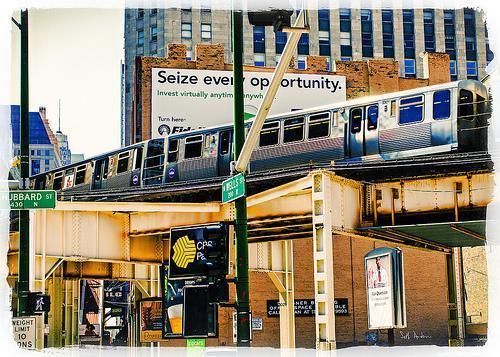How many cars are on the railway?
Give a very brief answer. 3. 